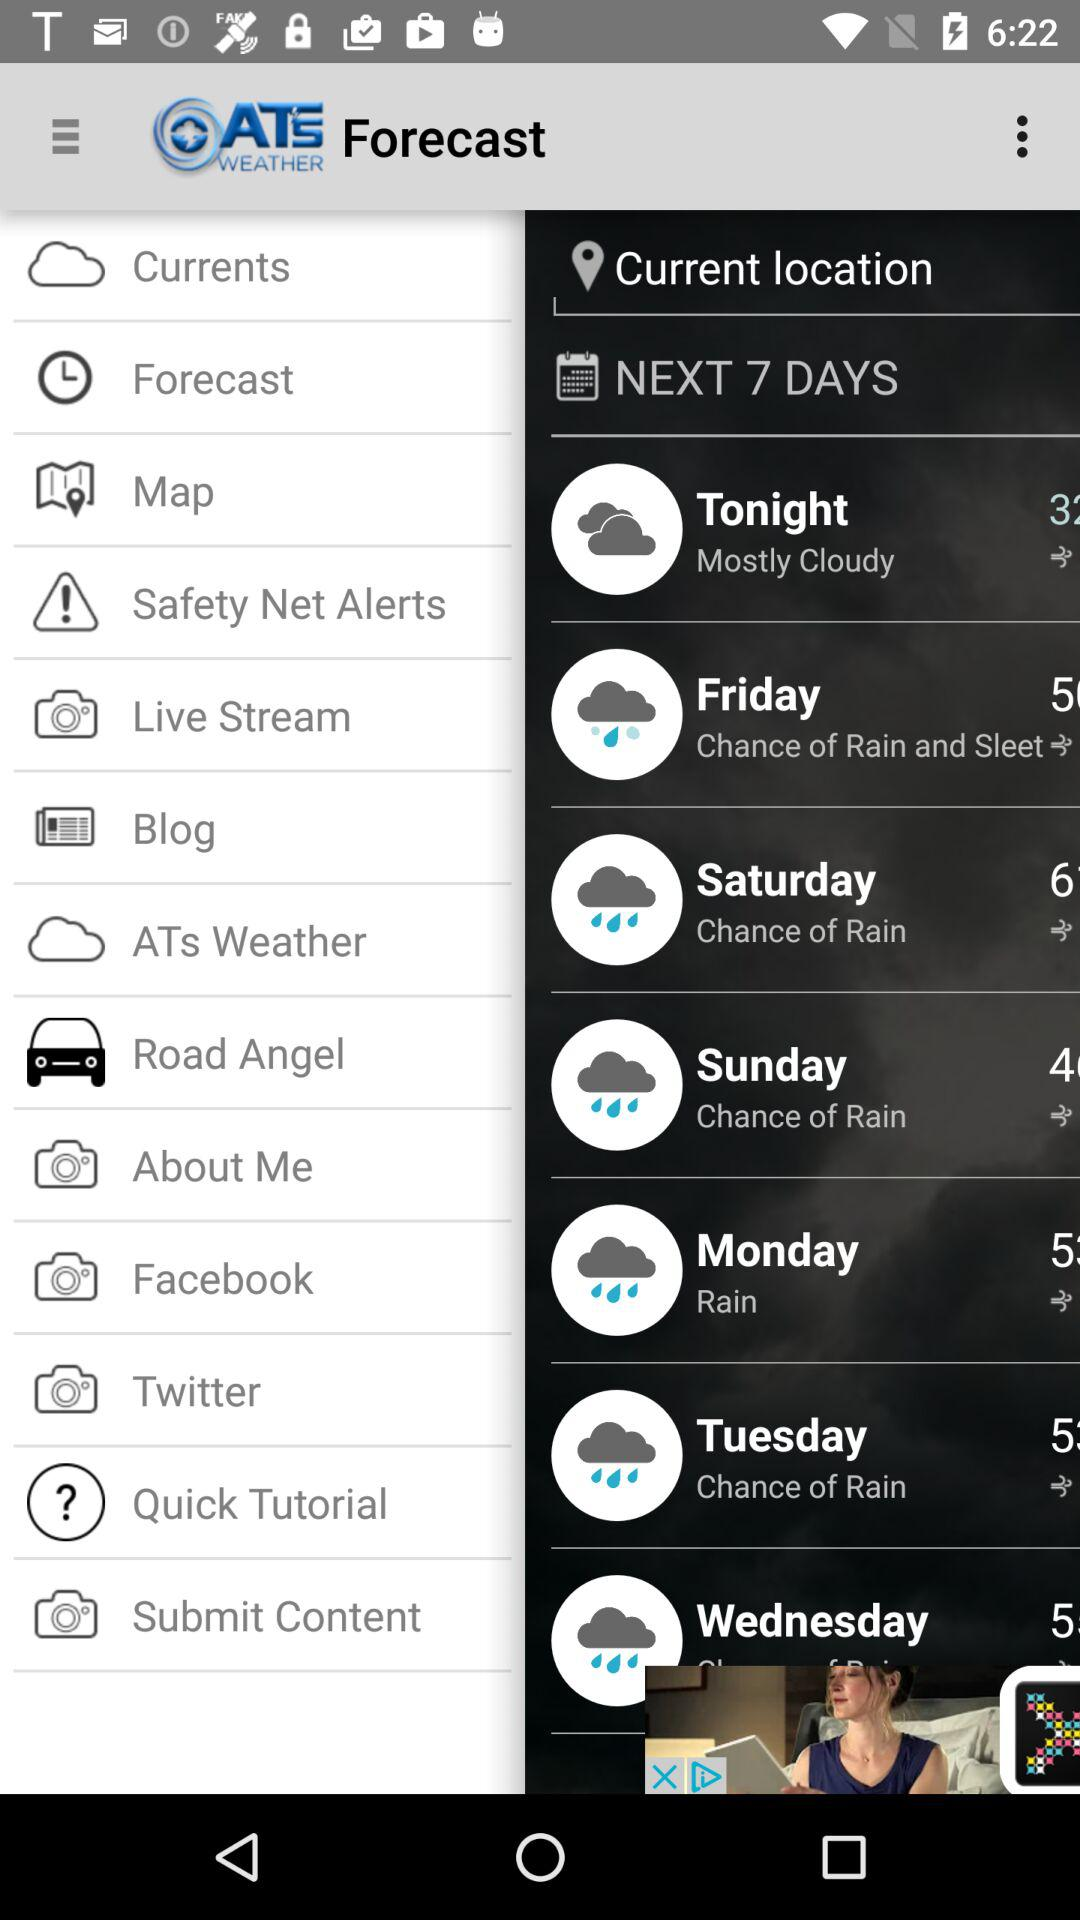What is temperature at tuesday?
When the provided information is insufficient, respond with <no answer>. <no answer> 